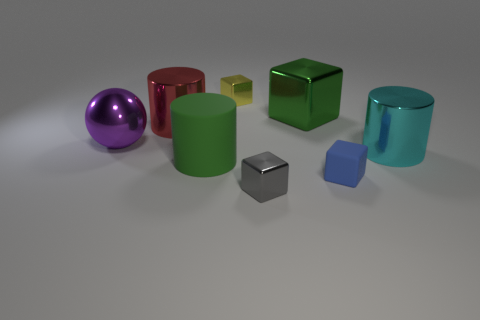Is there any other thing that has the same color as the rubber cube?
Provide a short and direct response. No. There is a green block that is made of the same material as the yellow block; what is its size?
Offer a very short reply. Large. What is the material of the large cylinder that is on the right side of the cylinder in front of the metal cylinder right of the small yellow metallic block?
Make the answer very short. Metal. Is the number of tiny red things less than the number of spheres?
Make the answer very short. Yes. Does the green cube have the same material as the large purple sphere?
Your answer should be very brief. Yes. The other big object that is the same color as the big matte object is what shape?
Keep it short and to the point. Cube. Does the cylinder that is right of the small yellow object have the same color as the big shiny block?
Make the answer very short. No. How many small gray objects are on the left side of the small shiny thing in front of the matte cylinder?
Provide a short and direct response. 0. What color is the rubber cylinder that is the same size as the green block?
Your answer should be very brief. Green. There is a big green object that is in front of the large purple metallic sphere; what material is it?
Give a very brief answer. Rubber. 